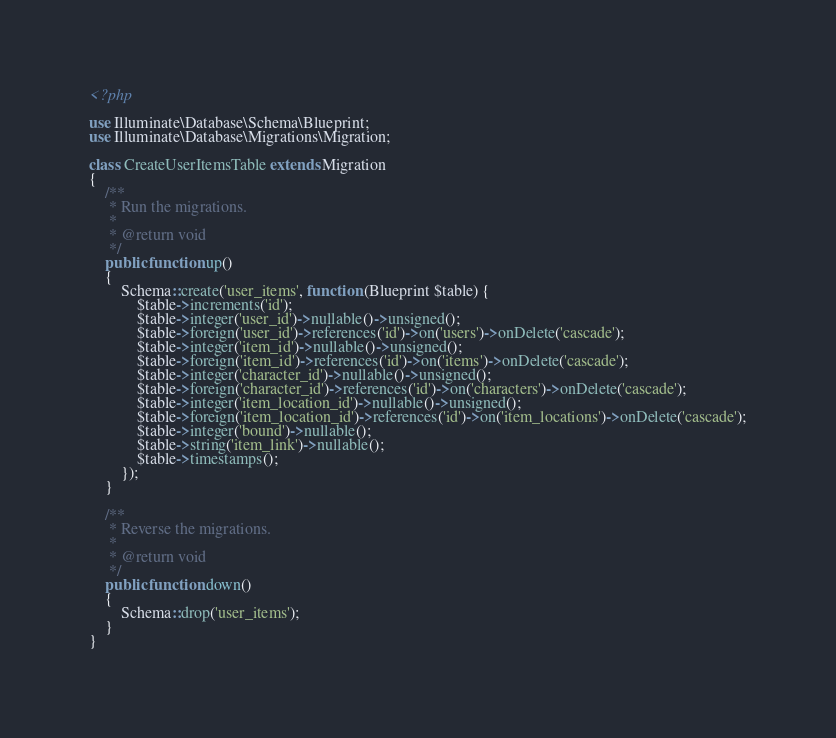Convert code to text. <code><loc_0><loc_0><loc_500><loc_500><_PHP_><?php

use Illuminate\Database\Schema\Blueprint;
use Illuminate\Database\Migrations\Migration;

class CreateUserItemsTable extends Migration
{
    /**
     * Run the migrations.
     *
     * @return void
     */
    public function up()
    {
        Schema::create('user_items', function (Blueprint $table) {
            $table->increments('id');
            $table->integer('user_id')->nullable()->unsigned();
			$table->foreign('user_id')->references('id')->on('users')->onDelete('cascade');
            $table->integer('item_id')->nullable()->unsigned();
			$table->foreign('item_id')->references('id')->on('items')->onDelete('cascade');
            $table->integer('character_id')->nullable()->unsigned();
			$table->foreign('character_id')->references('id')->on('characters')->onDelete('cascade');
			$table->integer('item_location_id')->nullable()->unsigned();
			$table->foreign('item_location_id')->references('id')->on('item_locations')->onDelete('cascade');
			$table->integer('bound')->nullable();
			$table->string('item_link')->nullable();
            $table->timestamps();
        });
    }

    /**
     * Reverse the migrations.
     *
     * @return void
     */
    public function down()
    {
        Schema::drop('user_items');
    }
}
</code> 